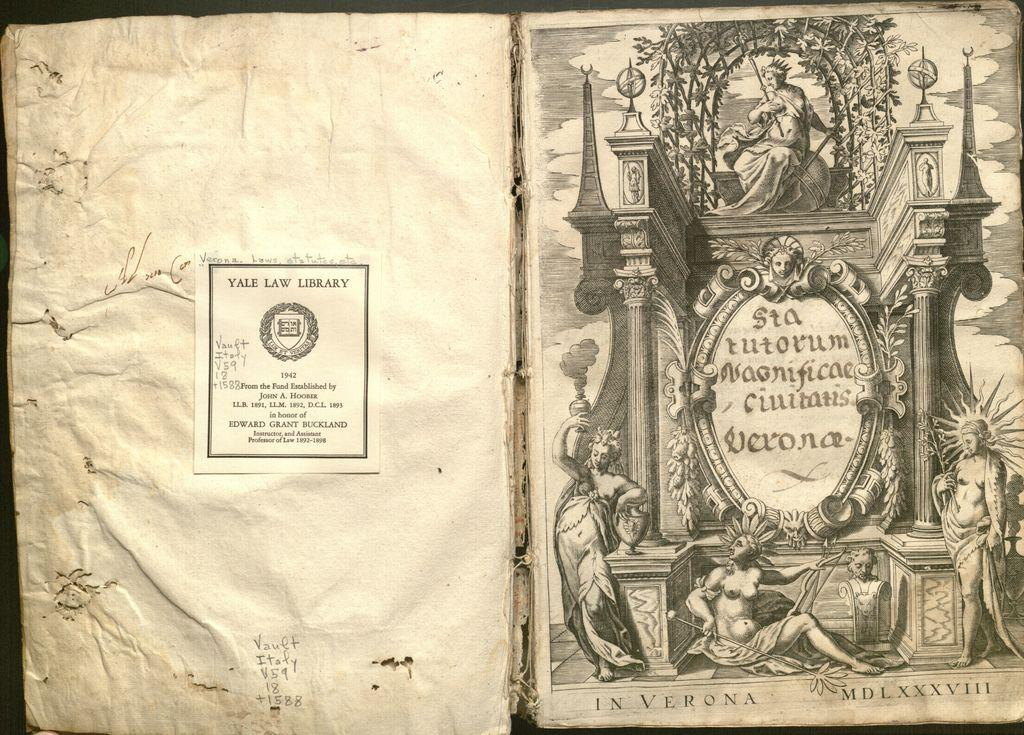<image>
Write a terse but informative summary of the picture. An old book with crumbled pages bars a sticker for the Yale Law Library. 